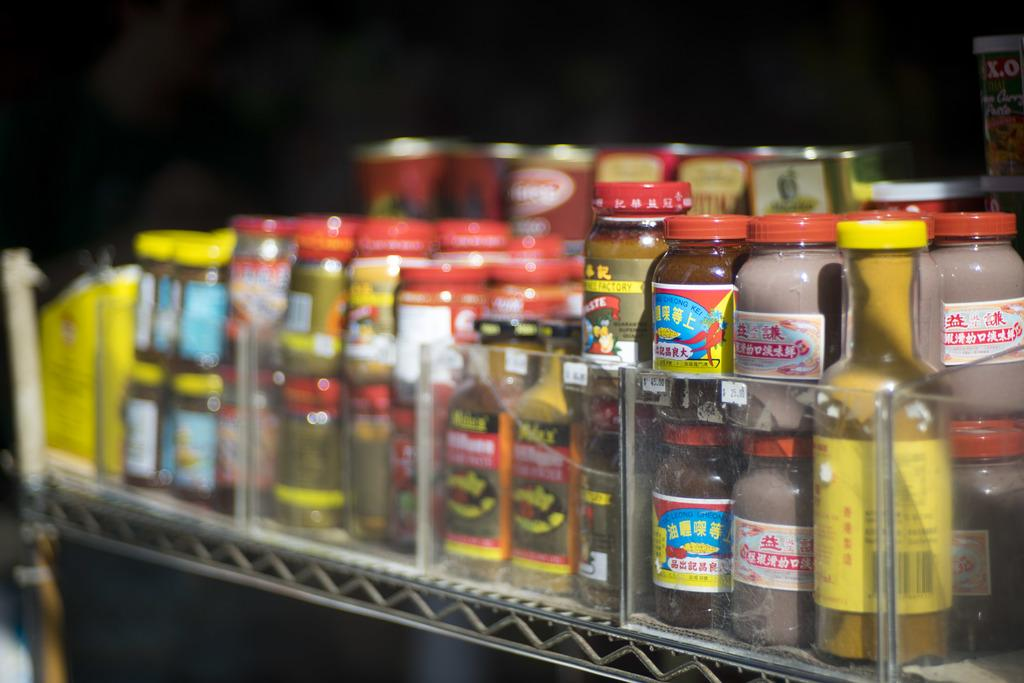What is the main object in the image? There is a rack in the image. How are the bottles arranged on the rack? The bottles are arranged in a sequence manner on the rack. Is there a girl playing with a cart in the image? There is no girl or cart present in the image. What does the peace symbol look like in the image? There is no peace symbol present in the image. 